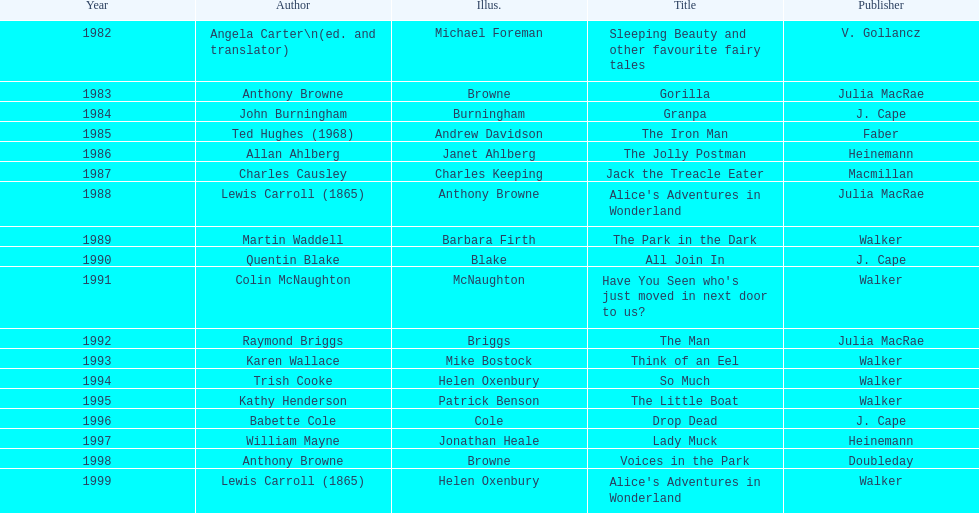Could you help me parse every detail presented in this table? {'header': ['Year', 'Author', 'Illus.', 'Title', 'Publisher'], 'rows': [['1982', 'Angela Carter\\n(ed. and translator)', 'Michael Foreman', 'Sleeping Beauty and other favourite fairy tales', 'V. Gollancz'], ['1983', 'Anthony Browne', 'Browne', 'Gorilla', 'Julia MacRae'], ['1984', 'John Burningham', 'Burningham', 'Granpa', 'J. Cape'], ['1985', 'Ted Hughes (1968)', 'Andrew Davidson', 'The Iron Man', 'Faber'], ['1986', 'Allan Ahlberg', 'Janet Ahlberg', 'The Jolly Postman', 'Heinemann'], ['1987', 'Charles Causley', 'Charles Keeping', 'Jack the Treacle Eater', 'Macmillan'], ['1988', 'Lewis Carroll (1865)', 'Anthony Browne', "Alice's Adventures in Wonderland", 'Julia MacRae'], ['1989', 'Martin Waddell', 'Barbara Firth', 'The Park in the Dark', 'Walker'], ['1990', 'Quentin Blake', 'Blake', 'All Join In', 'J. Cape'], ['1991', 'Colin McNaughton', 'McNaughton', "Have You Seen who's just moved in next door to us?", 'Walker'], ['1992', 'Raymond Briggs', 'Briggs', 'The Man', 'Julia MacRae'], ['1993', 'Karen Wallace', 'Mike Bostock', 'Think of an Eel', 'Walker'], ['1994', 'Trish Cooke', 'Helen Oxenbury', 'So Much', 'Walker'], ['1995', 'Kathy Henderson', 'Patrick Benson', 'The Little Boat', 'Walker'], ['1996', 'Babette Cole', 'Cole', 'Drop Dead', 'J. Cape'], ['1997', 'William Mayne', 'Jonathan Heale', 'Lady Muck', 'Heinemann'], ['1998', 'Anthony Browne', 'Browne', 'Voices in the Park', 'Doubleday'], ['1999', 'Lewis Carroll (1865)', 'Helen Oxenbury', "Alice's Adventures in Wonderland", 'Walker']]} How many number of titles are listed for the year 1991? 1. 